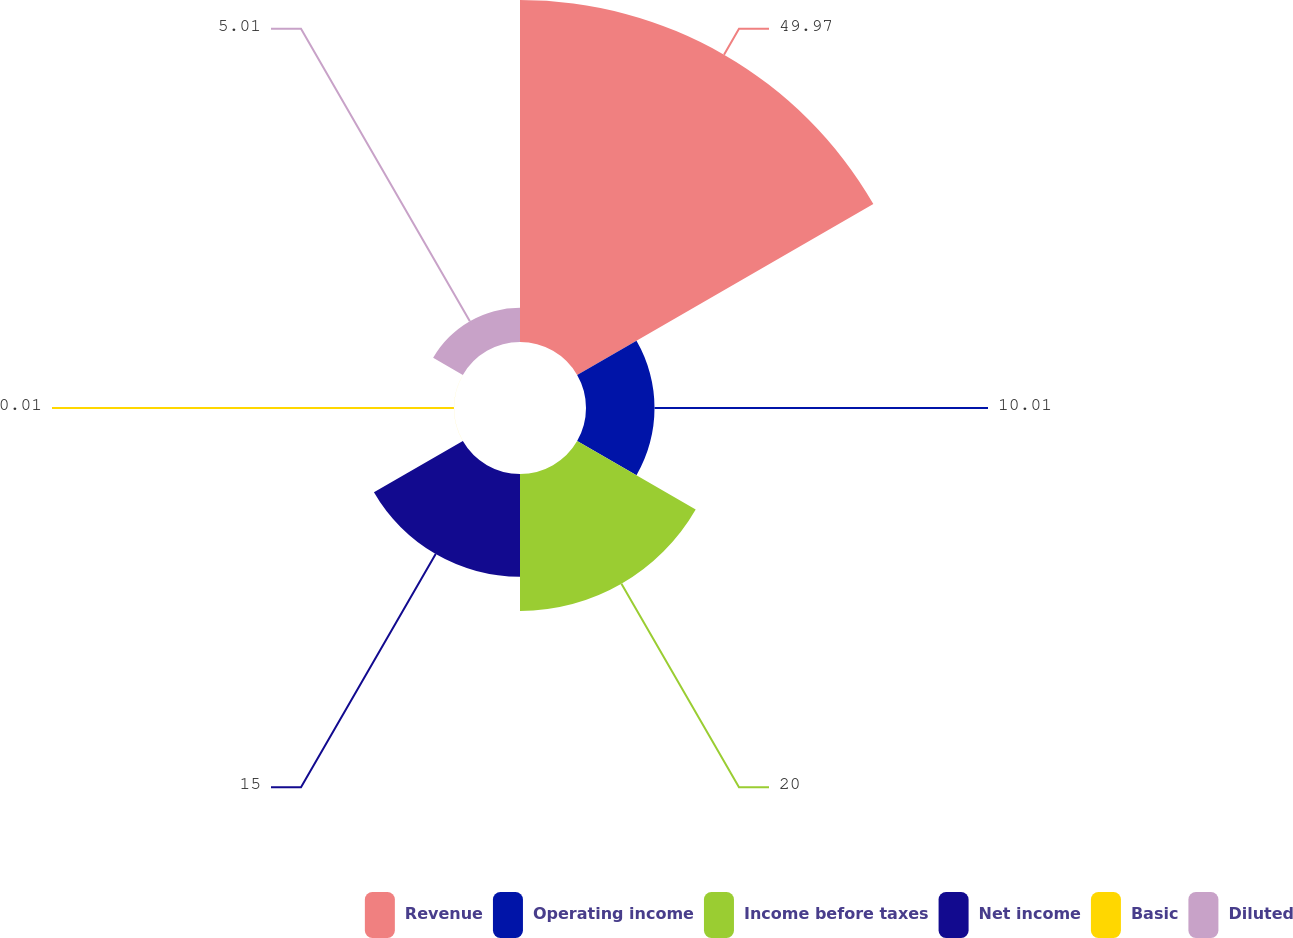Convert chart to OTSL. <chart><loc_0><loc_0><loc_500><loc_500><pie_chart><fcel>Revenue<fcel>Operating income<fcel>Income before taxes<fcel>Net income<fcel>Basic<fcel>Diluted<nl><fcel>49.97%<fcel>10.01%<fcel>20.0%<fcel>15.0%<fcel>0.01%<fcel>5.01%<nl></chart> 